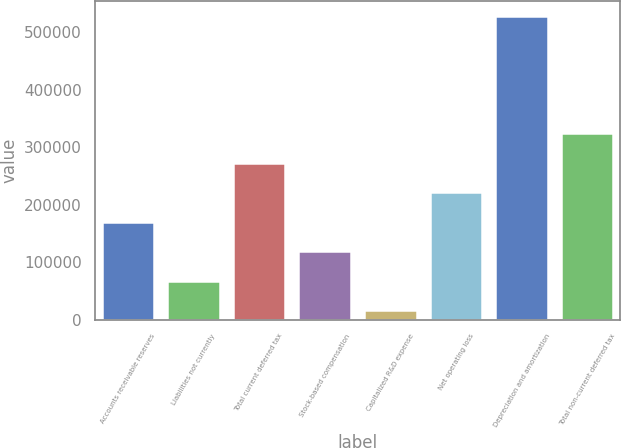Convert chart. <chart><loc_0><loc_0><loc_500><loc_500><bar_chart><fcel>Accounts receivable reserves<fcel>Liabilities not currently<fcel>Total current deferred tax<fcel>Stock-based compensation<fcel>Capitalized R&D expense<fcel>Net operating loss<fcel>Depreciation and amortization<fcel>Total non-current deferred tax<nl><fcel>170268<fcel>68022<fcel>272514<fcel>119145<fcel>16899<fcel>221391<fcel>528129<fcel>323637<nl></chart> 